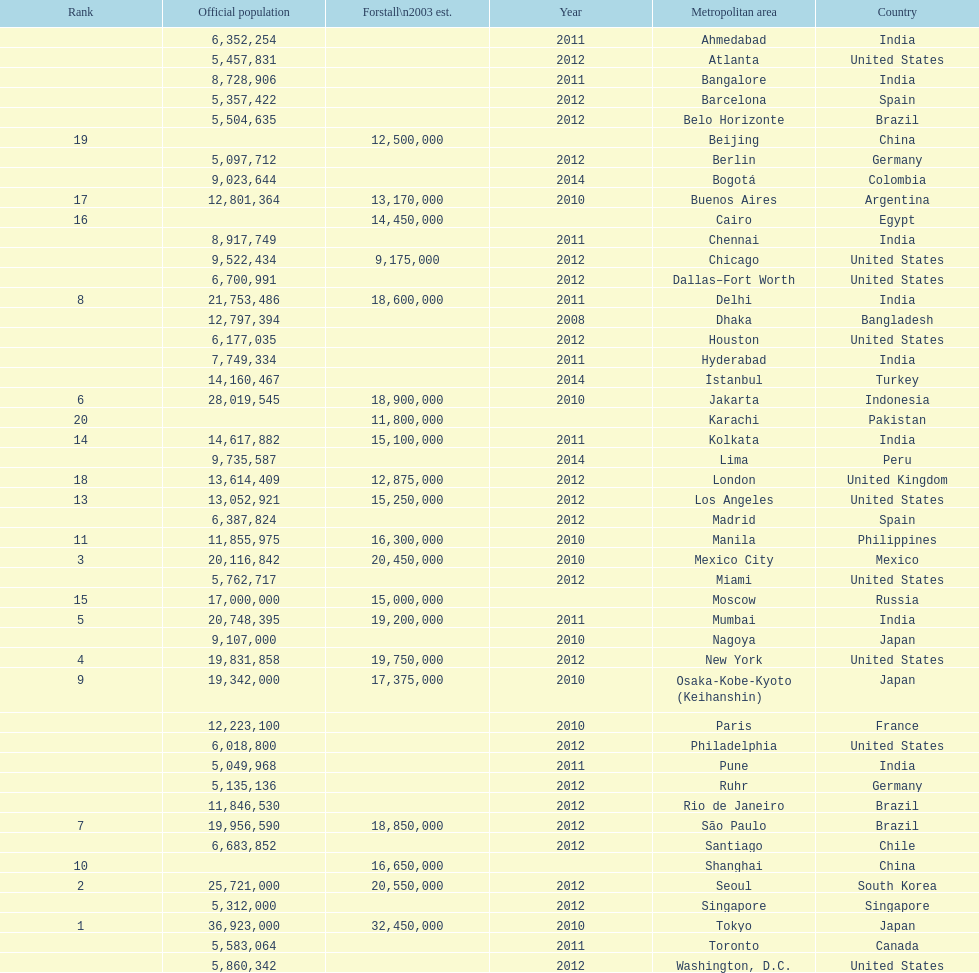Which area is listed above chicago? Chennai. 